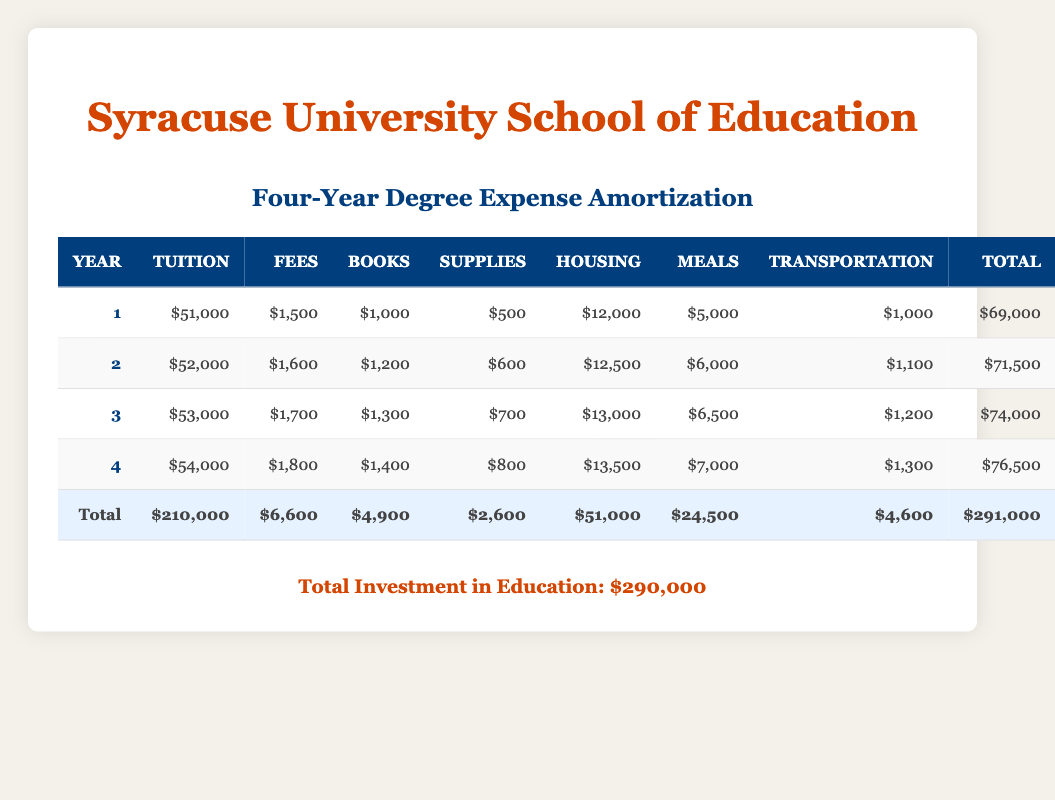What was the total yearly expense for the first year? The total yearly expense for the first year is listed in the table under the "Total" column for Year 1. It shows $69,000.
Answer: 69,000 What is the tuition fee for the fourth year? The tuition fee for Year 4 is specified in the table under the "Tuition" column for Year 4. It shows $54,000.
Answer: 54,000 What is the average expense for housing over the four years? To find the average expense for housing, sum the housing expenses for all four years: (12,000 + 12,500 + 13,000 + 13,500) = 51,000. Then, divide by the number of years: 51,000 / 4 = 12,750.
Answer: 12,750 Was the total investment in education higher than $300,000? The total investment shown at the bottom of the table is $290,000. Since $290,000 is less than $300,000, the answer is no.
Answer: No Which year saw the largest increase in total yearly expenses compared to the previous year? By comparing the total yearly expenses for each year: Year 1 = 69,000, Year 2 = 71,500 (increase of 2,500), Year 3 = 74,000 (increase of 2,500), Year 4 = 76,500 (increase of 2,500). All years have the same increase, hence any of the years can be considered as the one with the largest increase.
Answer: Any year (all years increased by the same amount) What is the total amount spent on books throughout the four years? To calculate the total amount spent on books, sum the amounts from each year: (1,000 + 1,200 + 1,300 + 1,400) = 4,900.
Answer: 4,900 Is the fee for the second year greater than the transportation cost in the fourth year? The fee for Year 2 is $1,600, and the transportation cost for Year 4 is $1,300. Since $1,600 is greater than $1,300, the answer is yes.
Answer: Yes What was the increase in total yearly expense from the second year to the third year? To find the increase, subtract the total for Year 2 from Year 3: 74,000 (Year 3) - 71,500 (Year 2) = 2,500.
Answer: 2,500 What proportion of the total educational expenses is spent on meals in the third year? The total yearly expense for Year 3 is $74,000, and the amount spent on meals is $6,500. To find the proportion, divide: 6,500 / 74,000 = 0.0878 or approximately 8.78%.
Answer: 8.78% 